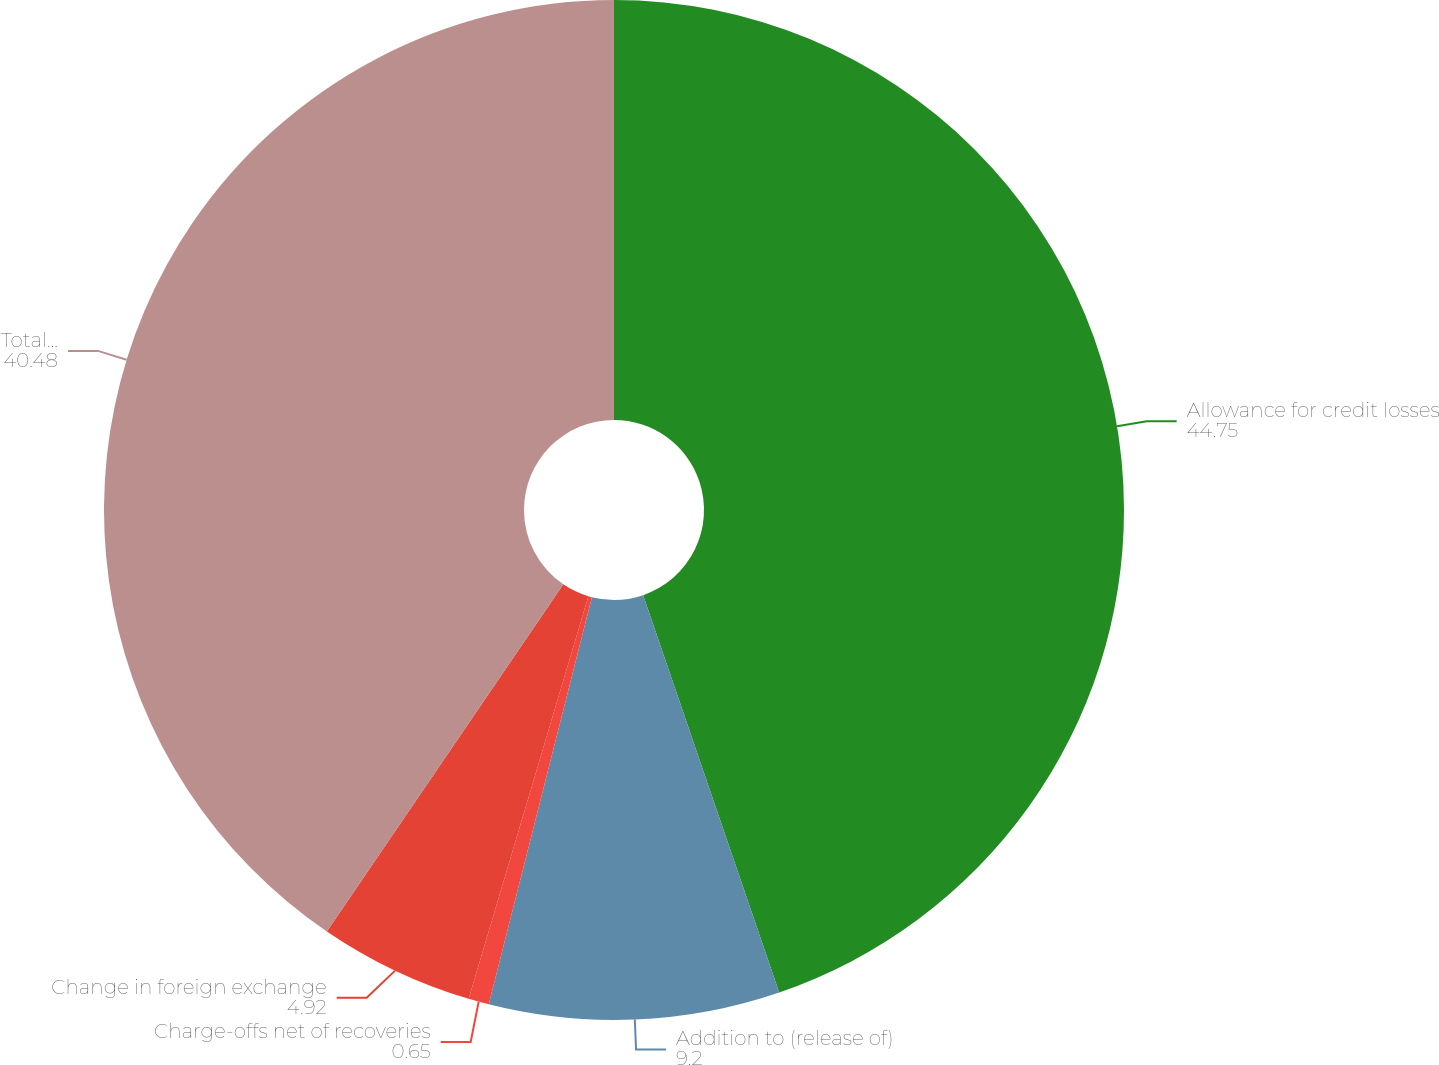Convert chart. <chart><loc_0><loc_0><loc_500><loc_500><pie_chart><fcel>Allowance for credit losses<fcel>Addition to (release of)<fcel>Charge-offs net of recoveries<fcel>Change in foreign exchange<fcel>Total ending balance<nl><fcel>44.75%<fcel>9.2%<fcel>0.65%<fcel>4.92%<fcel>40.48%<nl></chart> 